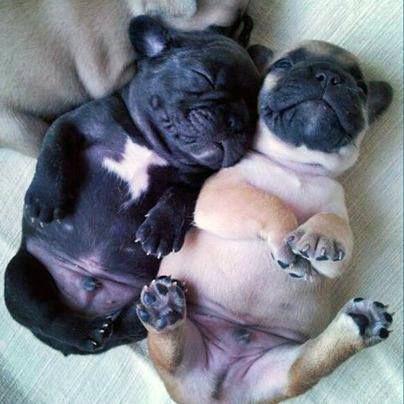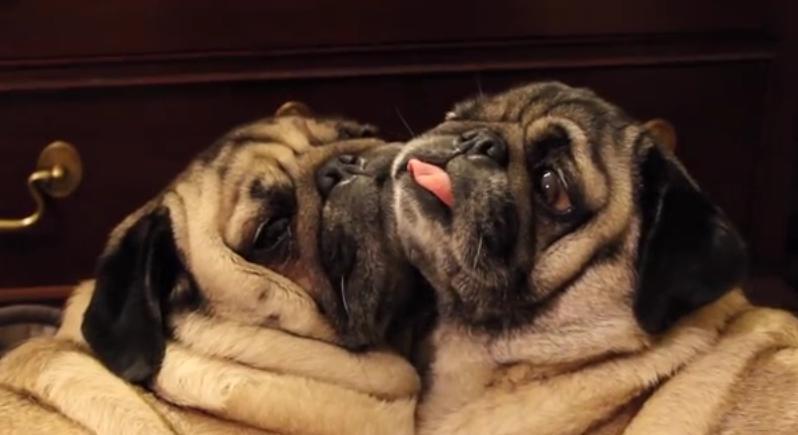The first image is the image on the left, the second image is the image on the right. Examine the images to the left and right. Is the description "At least one of the images shows a dog with a visible tongue outside of it's mouth." accurate? Answer yes or no. Yes. 